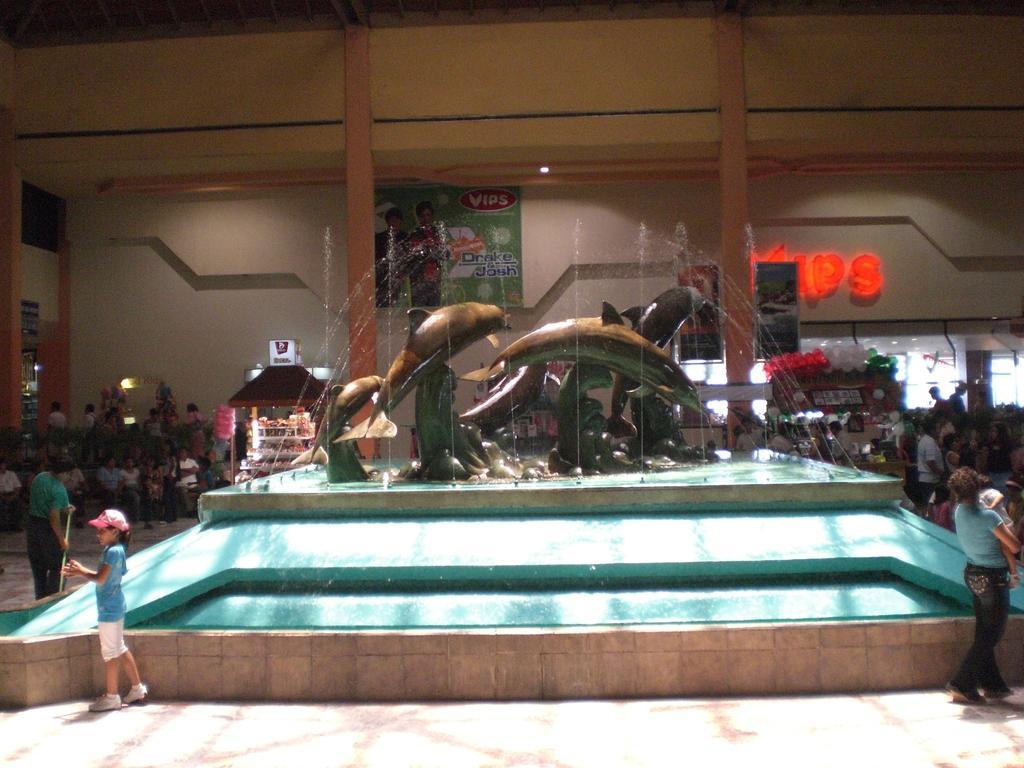In one or two sentences, can you explain what this image depicts? This image is taken indoors. At the bottom of the image there is a floor. In the background there is a wall with a text on it and there is a board with a text on it. There are two pillars. There is a stall with a few things in it. Many people are standing on the floor and a few are walking. In the middle of the image there is a fountain with a few artificial dolphins. 